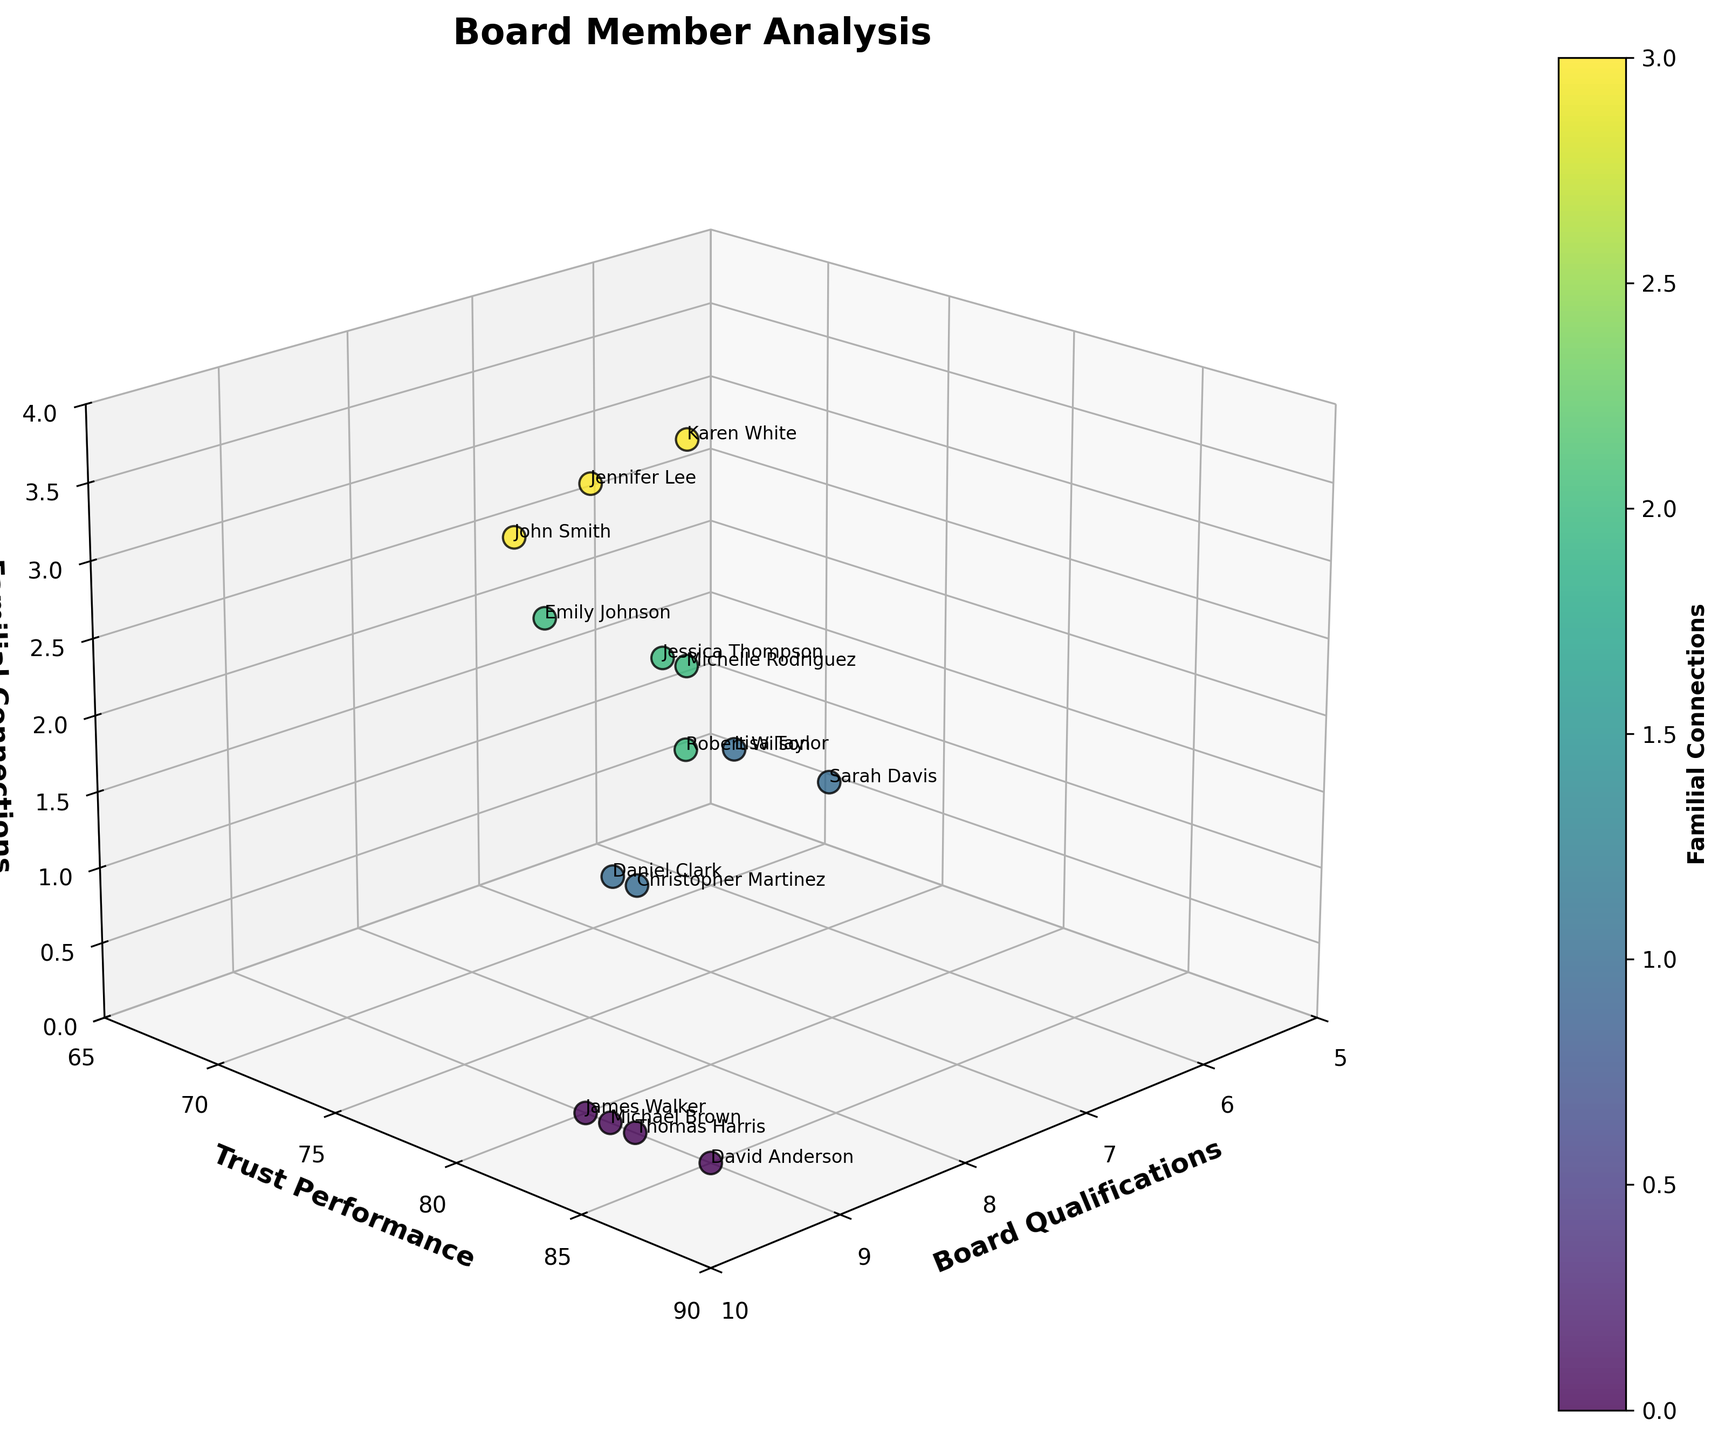What does the title of the figure say? The title of the figure is usually located at the top of the plot. By referring to that section, the title states the main subject and purpose of the plot.
Answer: Board Member Analysis Which axis represents Trust Performance? Each axis is labeled with a different aspect of the data. The label for the vertical (y) axis indicates it represents Trust Performance.
Answer: y-axis What color seems to be used predominantly for data points? The scatter plot uses a colormap to distinguish different values. By observing the scatter plot, we can see a gradient color scale with shades leaning towards green and blue.
Answer: Green and blue shades How many data points are there in total? By identifying the number of labeled names or individual points on the scatter plot, we can total the number of board members represented. Here, we count the data points to see there are 15.
Answer: 15 Which board member has the highest Trust Performance score? To find this, locate the highest point on the Trust Performance axis, identify the associated data point, and read the label next to it.
Answer: David Anderson Which board member has the lowest Board Qualifications score? By looking along the Board Qualifications axis, finding the point closest to the minimum value, and identifying the label next to it, we see this board member.
Answer: Sarah Davis/Karen White/Lisa Taylor (all with a score of 6) Is there a board member with high Board Qualifications and zero Familial Connections? By looking at the points with high Board Qualifications (8 or 9) and checking if any of them have zero on the Familial Connections axis, we identify such members.
Answer: Yes (e.g., Michael Brown, David Anderson, Thomas Harris, James Walker) What is the average Trust Performance score of members with 3 Familial Connections? We need to first identify the Trust Performance scores of members with 3 Familial Connections and then calculate their average. Those members have Trust Performance scores of 72, 70, and 69. The sum is 72 + 70 + 69 = 211. The average is 211/3.
Answer: 70.3 Does higher Board Qualifications correlate with lower Familial Connections? To answer this, we look at the distribution of points across the Board Qualifications and Familial Connections axes. Points with higher Board Qualifications (8 or 9) tend to have lower Familial Connections (0-1).
Answer: Generally, yes Which board members with high Familial Connections also have a high Trust Performance? High Familial Connections are 2 or 3. By examining the points corresponding to both high Trust Performance (above 75) and high Familial Connections, we identify those board members.
Answer: Robert Wilson, Michelle Rodriguez 